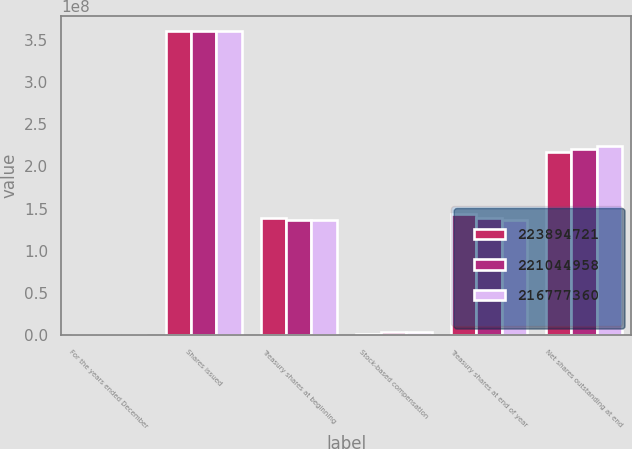<chart> <loc_0><loc_0><loc_500><loc_500><stacked_bar_chart><ecel><fcel>For the years ended December<fcel>Shares issued<fcel>Treasury shares at beginning<fcel>Stock-based compensation<fcel>Treasury shares at end of year<fcel>Net shares outstanding at end<nl><fcel>2.23895e+08<fcel>2015<fcel>3.59902e+08<fcel>1.38857e+08<fcel>1.77684e+06<fcel>1.43124e+08<fcel>2.16777e+08<nl><fcel>2.21045e+08<fcel>2014<fcel>3.59902e+08<fcel>1.36007e+08<fcel>3.67651e+06<fcel>1.38857e+08<fcel>2.21045e+08<nl><fcel>2.16777e+08<fcel>2013<fcel>3.59902e+08<fcel>1.36116e+08<fcel>3.65583e+06<fcel>1.36007e+08<fcel>2.23895e+08<nl></chart> 